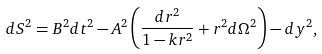Convert formula to latex. <formula><loc_0><loc_0><loc_500><loc_500>d S ^ { 2 } = B ^ { 2 } d t ^ { 2 } - A ^ { 2 } \left ( \frac { d r ^ { 2 } } { 1 - k r ^ { 2 } } + r ^ { 2 } d \Omega ^ { 2 } \right ) - d y ^ { 2 } ,</formula> 